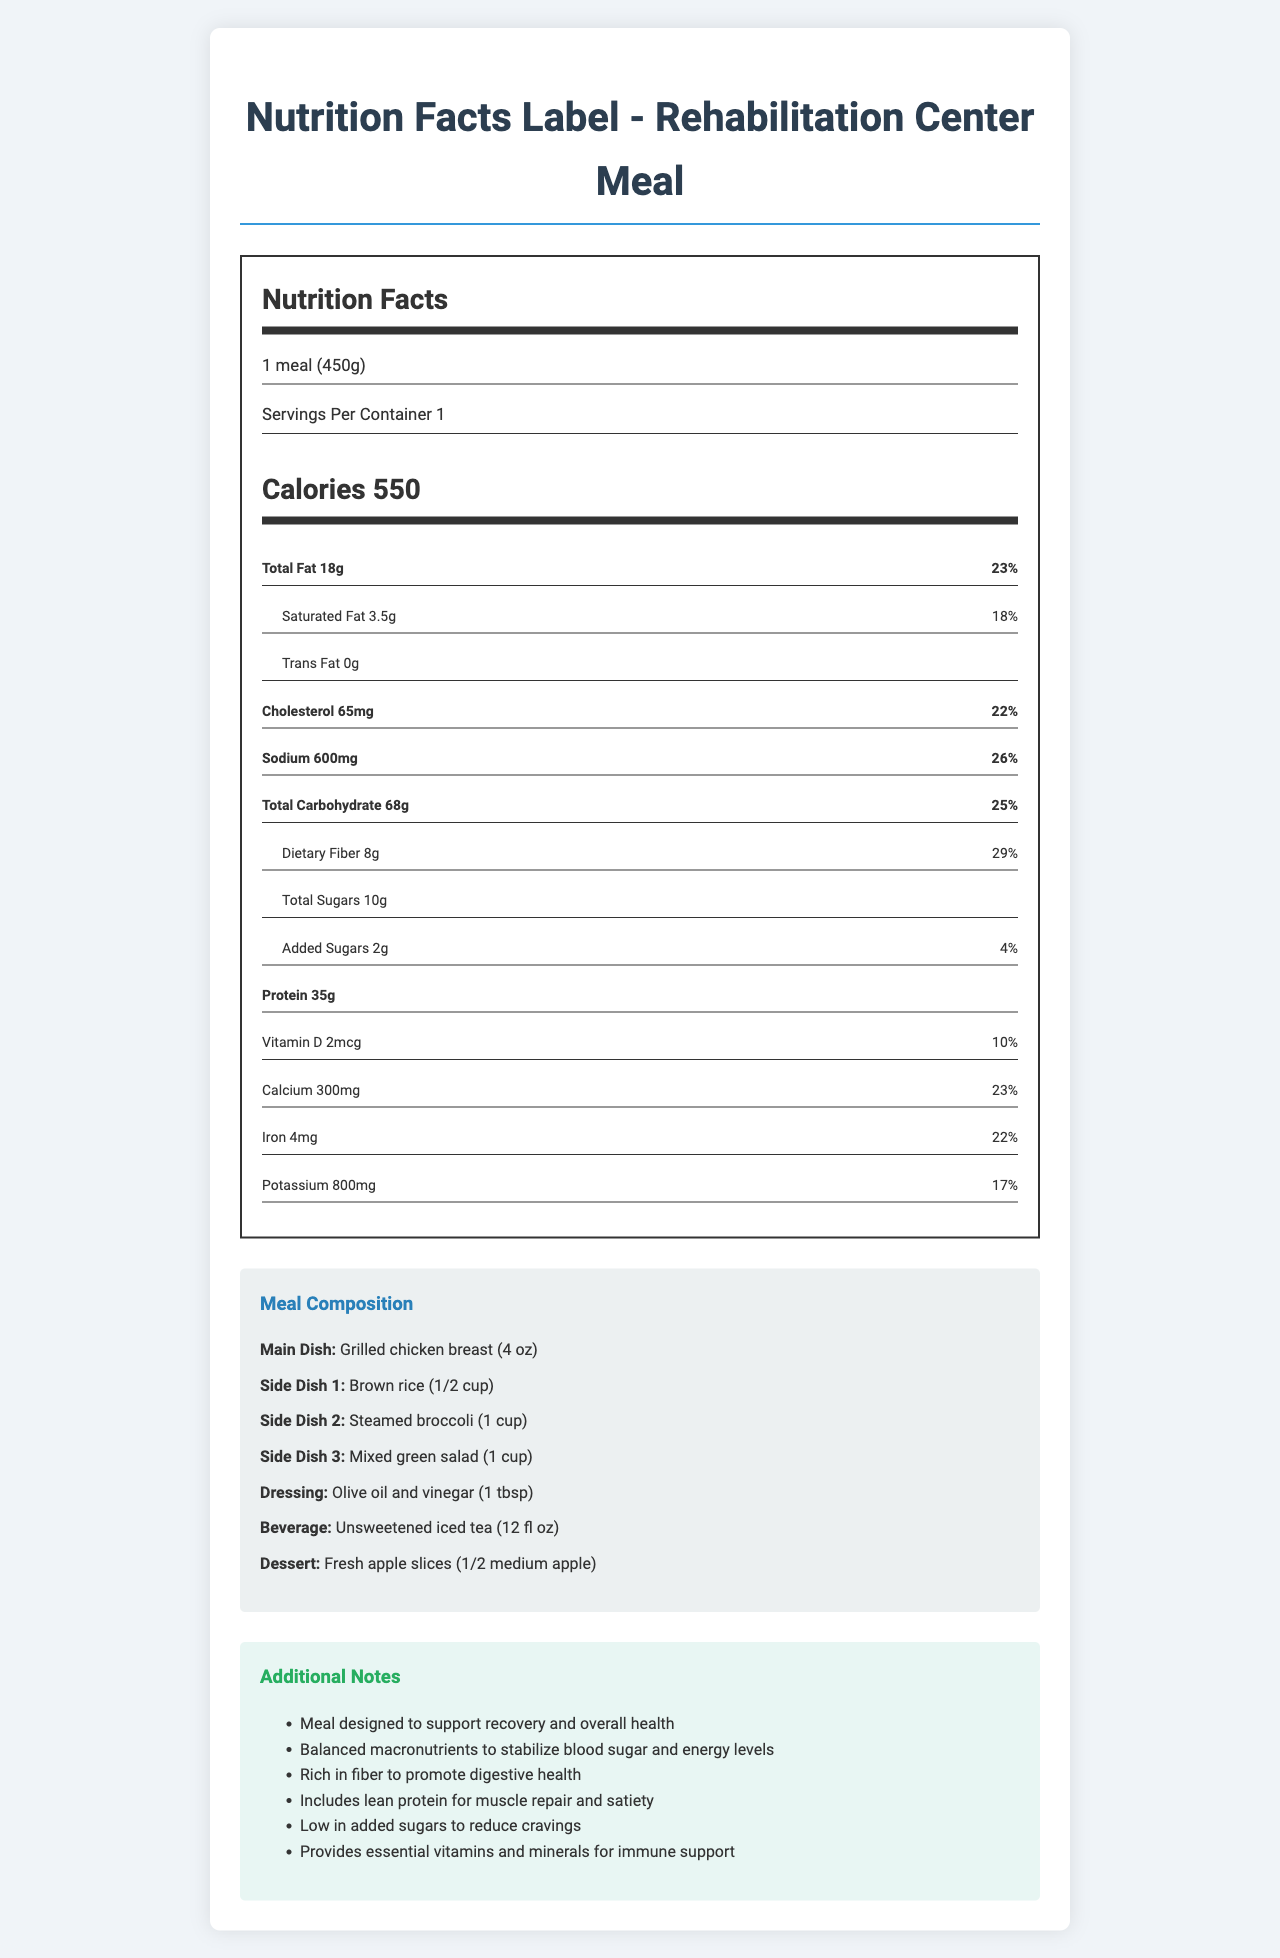what is the serving size of the meal? The serving size is indicated at the beginning of the Nutrition Facts section as "1 meal (450g)".
Answer: 1 meal (450g) how many calories does the meal contain? The document shows the calorie content in the Nutrition Facts section as 550 calories.
Answer: 550 what is the amount of dietary fiber in the meal? The amount of dietary fiber is listed in the Nutrition Facts section with the value "8g".
Answer: 8g what is the daily value percentage of sodium in the meal? The percentage of daily value for sodium is mentioned in the Nutrition Facts section, stating "26%".
Answer: 26% which nutrient has the lowest daily value percentage? The added sugars have the lowest daily value percentage listed as "4%" in the Nutrition Facts section.
Answer: Added Sugars what is the main dish included in the meal composition? The main dish is detailed in the Meal Composition section as "Grilled chicken breast (4 oz)".
Answer: Grilled chicken breast (4 oz) what are the side dishes included in the meal? The side dishes are listed in the Meal Composition section as "Brown rice (1/2 cup)", "Steamed broccoli (1 cup)", and "Mixed green salad (1 cup)".
Answer: Brown rice, Steamed broccoli, Mixed green salad what beverage accompanies the meal? The beverage for the meal is specified in the Meal Composition section as "Unsweetened iced tea (12 fl oz)".
Answer: Unsweetened iced tea (12 fl oz) what is the protein content of the meal? A. 18g B. 35g C. 50g D. 68g The Nutrition Facts section lists the protein content as "35g", making option B the correct answer.
Answer: B which vitamin or mineral provides 22% of the daily value? A. Iron B. Potassium C. Calcium D. Vitamin D Iron is listed in the Nutrition Facts section as providing "22%" of the daily value, making option A the correct answer.
Answer: A does the meal include any trans fats? The Nutrition Facts indicates that the trans fat content is "0g", meaning the meal does not include any trans fats.
Answer: No describe the main idea of the document. The document is structured with detailed sections on serving size, calories, and nutrient contents, followed by a breakdown of the meal's main dish, side dishes, dressing, beverage, and dessert. Additional notes highlight the meal's design principles, such as balanced macronutrients, high fiber, low added sugars, and essential vitamins and minerals.
Answer: The document provides comprehensive nutritional information about a balanced meal designed for patients in a rehabilitation center, listing macronutrient contents, vitamins, minerals, and meal components to support recovery and health. what is the dietary goal of the meal? The additional notes section specifies that the meal is designed to stabilize blood sugar and energy levels, promote digestive health, provide lean protein for muscle repair, and reduce cravings through low added sugars.
Answer: Stabilize blood sugar and energy levels, promote digestive health, support muscle repair, and reduce cravings. does the meal include a dessert? The Meal Composition section lists "Fresh apple slices (1/2 medium apple)" as the dessert.
Answer: Yes what percentage of the daily value does vitamin D provide? The amount and daily value percentage for vitamin D is listed in the Nutrition Facts section as "2mcg" and "10%" respectively.
Answer: 10% who prepared the meal plan for the rehabilitation center? The document does not provide any details about the person or team who prepared the meal plan. Thus, the answer cannot be determined from the visual information provided.
Answer: Not enough information 